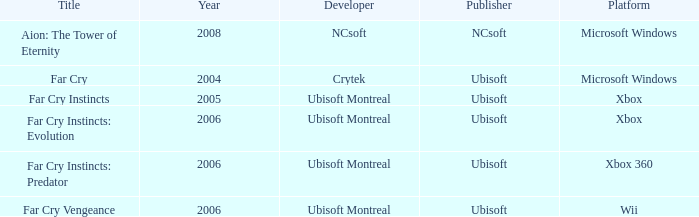Which xbox 360 game was launched in a year earlier than 2008? Far Cry Instincts: Predator. 